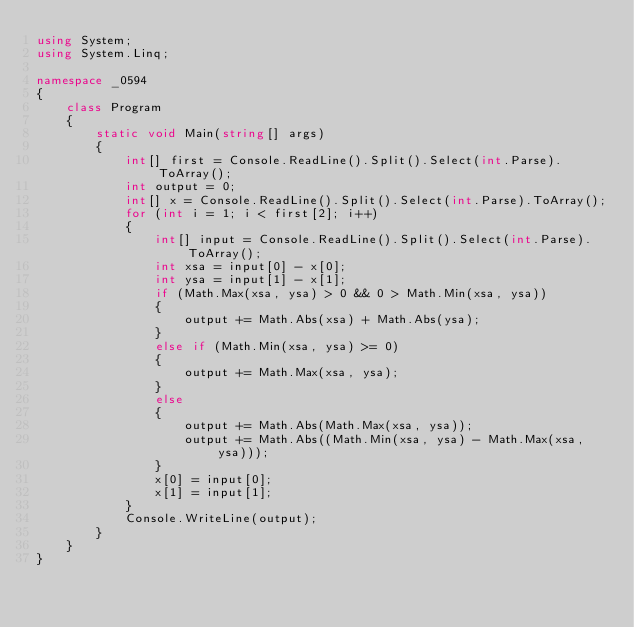<code> <loc_0><loc_0><loc_500><loc_500><_C#_>using System;
using System.Linq;

namespace _0594
{
    class Program
    {
        static void Main(string[] args)
        {
            int[] first = Console.ReadLine().Split().Select(int.Parse).ToArray();
            int output = 0;
            int[] x = Console.ReadLine().Split().Select(int.Parse).ToArray();
            for (int i = 1; i < first[2]; i++)
            {
                int[] input = Console.ReadLine().Split().Select(int.Parse).ToArray();
                int xsa = input[0] - x[0];
                int ysa = input[1] - x[1];
                if (Math.Max(xsa, ysa) > 0 && 0 > Math.Min(xsa, ysa))
                {
                    output += Math.Abs(xsa) + Math.Abs(ysa);
                }
                else if (Math.Min(xsa, ysa) >= 0)
                {
                    output += Math.Max(xsa, ysa);
                }
                else
                {
                    output += Math.Abs(Math.Max(xsa, ysa));
                    output += Math.Abs((Math.Min(xsa, ysa) - Math.Max(xsa, ysa)));
                }
                x[0] = input[0];
                x[1] = input[1];
            }
            Console.WriteLine(output);
        }
    }
}</code> 